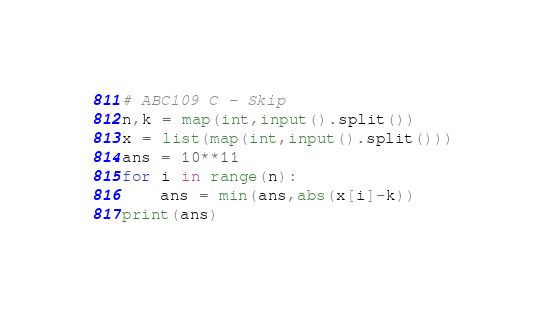Convert code to text. <code><loc_0><loc_0><loc_500><loc_500><_Python_># ABC109 C - Skip
n,k = map(int,input().split())
x = list(map(int,input().split()))
ans = 10**11
for i in range(n):
    ans = min(ans,abs(x[i]-k))
print(ans)
</code> 